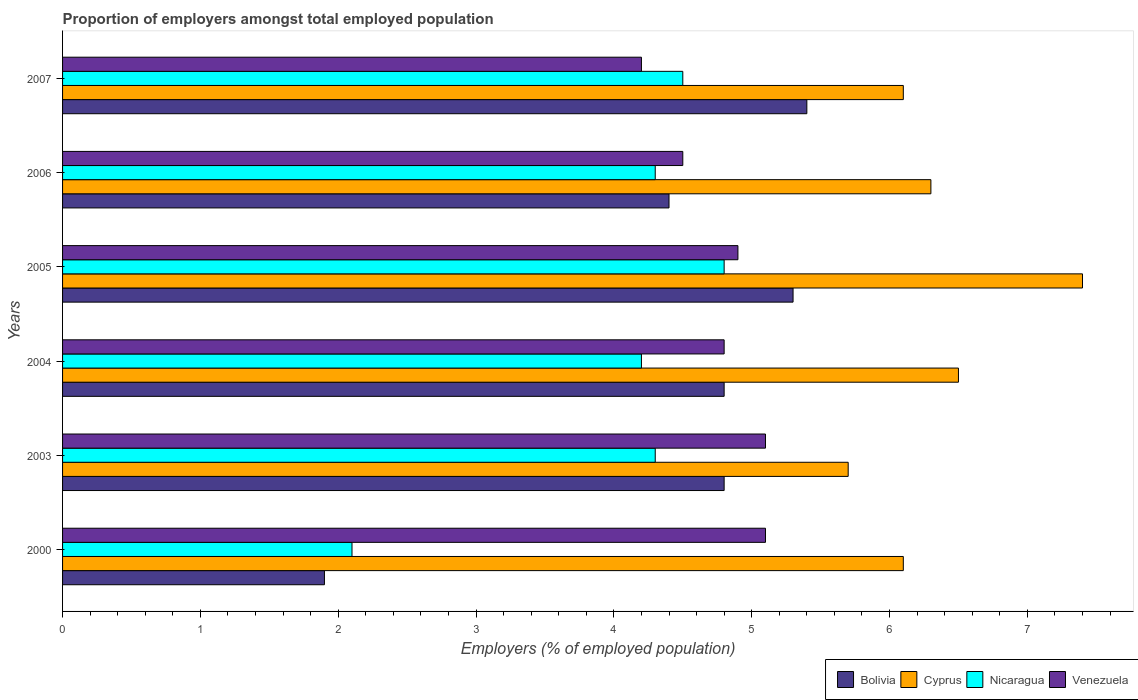How many different coloured bars are there?
Keep it short and to the point. 4. Are the number of bars per tick equal to the number of legend labels?
Your answer should be compact. Yes. How many bars are there on the 4th tick from the top?
Ensure brevity in your answer.  4. In how many cases, is the number of bars for a given year not equal to the number of legend labels?
Make the answer very short. 0. What is the proportion of employers in Venezuela in 2006?
Your response must be concise. 4.5. Across all years, what is the maximum proportion of employers in Venezuela?
Ensure brevity in your answer.  5.1. Across all years, what is the minimum proportion of employers in Venezuela?
Your answer should be very brief. 4.2. What is the total proportion of employers in Nicaragua in the graph?
Your answer should be compact. 24.2. What is the difference between the proportion of employers in Venezuela in 2000 and that in 2006?
Your response must be concise. 0.6. What is the difference between the proportion of employers in Cyprus in 2006 and the proportion of employers in Bolivia in 2007?
Your response must be concise. 0.9. What is the average proportion of employers in Bolivia per year?
Offer a very short reply. 4.43. In the year 2007, what is the difference between the proportion of employers in Nicaragua and proportion of employers in Venezuela?
Make the answer very short. 0.3. In how many years, is the proportion of employers in Venezuela greater than 7.2 %?
Provide a succinct answer. 0. What is the ratio of the proportion of employers in Bolivia in 2000 to that in 2006?
Provide a succinct answer. 0.43. What is the difference between the highest and the second highest proportion of employers in Nicaragua?
Keep it short and to the point. 0.3. What is the difference between the highest and the lowest proportion of employers in Venezuela?
Keep it short and to the point. 0.9. In how many years, is the proportion of employers in Venezuela greater than the average proportion of employers in Venezuela taken over all years?
Offer a very short reply. 4. Is it the case that in every year, the sum of the proportion of employers in Bolivia and proportion of employers in Nicaragua is greater than the sum of proportion of employers in Cyprus and proportion of employers in Venezuela?
Keep it short and to the point. No. What does the 2nd bar from the top in 2000 represents?
Keep it short and to the point. Nicaragua. What does the 4th bar from the bottom in 2007 represents?
Offer a terse response. Venezuela. Are all the bars in the graph horizontal?
Keep it short and to the point. Yes. How many years are there in the graph?
Offer a terse response. 6. What is the difference between two consecutive major ticks on the X-axis?
Your answer should be compact. 1. Are the values on the major ticks of X-axis written in scientific E-notation?
Your answer should be very brief. No. Does the graph contain grids?
Your answer should be compact. No. What is the title of the graph?
Keep it short and to the point. Proportion of employers amongst total employed population. What is the label or title of the X-axis?
Ensure brevity in your answer.  Employers (% of employed population). What is the label or title of the Y-axis?
Offer a terse response. Years. What is the Employers (% of employed population) in Bolivia in 2000?
Provide a short and direct response. 1.9. What is the Employers (% of employed population) of Cyprus in 2000?
Provide a short and direct response. 6.1. What is the Employers (% of employed population) in Nicaragua in 2000?
Make the answer very short. 2.1. What is the Employers (% of employed population) in Venezuela in 2000?
Offer a very short reply. 5.1. What is the Employers (% of employed population) in Bolivia in 2003?
Provide a short and direct response. 4.8. What is the Employers (% of employed population) of Cyprus in 2003?
Make the answer very short. 5.7. What is the Employers (% of employed population) in Nicaragua in 2003?
Your answer should be compact. 4.3. What is the Employers (% of employed population) in Venezuela in 2003?
Your answer should be compact. 5.1. What is the Employers (% of employed population) of Bolivia in 2004?
Give a very brief answer. 4.8. What is the Employers (% of employed population) in Nicaragua in 2004?
Offer a terse response. 4.2. What is the Employers (% of employed population) of Venezuela in 2004?
Your response must be concise. 4.8. What is the Employers (% of employed population) in Bolivia in 2005?
Offer a very short reply. 5.3. What is the Employers (% of employed population) in Cyprus in 2005?
Offer a terse response. 7.4. What is the Employers (% of employed population) in Nicaragua in 2005?
Your answer should be very brief. 4.8. What is the Employers (% of employed population) of Venezuela in 2005?
Provide a succinct answer. 4.9. What is the Employers (% of employed population) of Bolivia in 2006?
Provide a succinct answer. 4.4. What is the Employers (% of employed population) of Cyprus in 2006?
Keep it short and to the point. 6.3. What is the Employers (% of employed population) in Nicaragua in 2006?
Provide a short and direct response. 4.3. What is the Employers (% of employed population) in Venezuela in 2006?
Offer a terse response. 4.5. What is the Employers (% of employed population) in Bolivia in 2007?
Your answer should be very brief. 5.4. What is the Employers (% of employed population) in Cyprus in 2007?
Provide a short and direct response. 6.1. What is the Employers (% of employed population) in Nicaragua in 2007?
Ensure brevity in your answer.  4.5. What is the Employers (% of employed population) in Venezuela in 2007?
Provide a short and direct response. 4.2. Across all years, what is the maximum Employers (% of employed population) in Bolivia?
Offer a terse response. 5.4. Across all years, what is the maximum Employers (% of employed population) in Cyprus?
Make the answer very short. 7.4. Across all years, what is the maximum Employers (% of employed population) of Nicaragua?
Ensure brevity in your answer.  4.8. Across all years, what is the maximum Employers (% of employed population) of Venezuela?
Provide a short and direct response. 5.1. Across all years, what is the minimum Employers (% of employed population) of Bolivia?
Ensure brevity in your answer.  1.9. Across all years, what is the minimum Employers (% of employed population) in Cyprus?
Keep it short and to the point. 5.7. Across all years, what is the minimum Employers (% of employed population) in Nicaragua?
Give a very brief answer. 2.1. Across all years, what is the minimum Employers (% of employed population) of Venezuela?
Give a very brief answer. 4.2. What is the total Employers (% of employed population) in Bolivia in the graph?
Ensure brevity in your answer.  26.6. What is the total Employers (% of employed population) in Cyprus in the graph?
Your answer should be compact. 38.1. What is the total Employers (% of employed population) in Nicaragua in the graph?
Provide a succinct answer. 24.2. What is the total Employers (% of employed population) of Venezuela in the graph?
Keep it short and to the point. 28.6. What is the difference between the Employers (% of employed population) in Venezuela in 2000 and that in 2003?
Your response must be concise. 0. What is the difference between the Employers (% of employed population) in Nicaragua in 2000 and that in 2004?
Provide a succinct answer. -2.1. What is the difference between the Employers (% of employed population) of Nicaragua in 2000 and that in 2005?
Keep it short and to the point. -2.7. What is the difference between the Employers (% of employed population) in Venezuela in 2000 and that in 2005?
Provide a succinct answer. 0.2. What is the difference between the Employers (% of employed population) in Bolivia in 2000 and that in 2006?
Offer a terse response. -2.5. What is the difference between the Employers (% of employed population) in Cyprus in 2000 and that in 2007?
Offer a very short reply. 0. What is the difference between the Employers (% of employed population) in Venezuela in 2000 and that in 2007?
Your answer should be compact. 0.9. What is the difference between the Employers (% of employed population) of Bolivia in 2003 and that in 2004?
Your response must be concise. 0. What is the difference between the Employers (% of employed population) of Cyprus in 2003 and that in 2004?
Provide a succinct answer. -0.8. What is the difference between the Employers (% of employed population) of Nicaragua in 2003 and that in 2004?
Your answer should be very brief. 0.1. What is the difference between the Employers (% of employed population) of Venezuela in 2003 and that in 2004?
Make the answer very short. 0.3. What is the difference between the Employers (% of employed population) of Bolivia in 2003 and that in 2006?
Ensure brevity in your answer.  0.4. What is the difference between the Employers (% of employed population) of Cyprus in 2003 and that in 2006?
Offer a very short reply. -0.6. What is the difference between the Employers (% of employed population) in Nicaragua in 2003 and that in 2006?
Your response must be concise. 0. What is the difference between the Employers (% of employed population) in Nicaragua in 2003 and that in 2007?
Make the answer very short. -0.2. What is the difference between the Employers (% of employed population) in Venezuela in 2003 and that in 2007?
Provide a succinct answer. 0.9. What is the difference between the Employers (% of employed population) of Cyprus in 2004 and that in 2005?
Offer a very short reply. -0.9. What is the difference between the Employers (% of employed population) of Nicaragua in 2004 and that in 2005?
Offer a very short reply. -0.6. What is the difference between the Employers (% of employed population) in Venezuela in 2004 and that in 2005?
Your answer should be compact. -0.1. What is the difference between the Employers (% of employed population) in Bolivia in 2004 and that in 2006?
Provide a short and direct response. 0.4. What is the difference between the Employers (% of employed population) of Nicaragua in 2004 and that in 2006?
Your answer should be very brief. -0.1. What is the difference between the Employers (% of employed population) of Venezuela in 2004 and that in 2006?
Ensure brevity in your answer.  0.3. What is the difference between the Employers (% of employed population) of Bolivia in 2004 and that in 2007?
Keep it short and to the point. -0.6. What is the difference between the Employers (% of employed population) of Nicaragua in 2004 and that in 2007?
Make the answer very short. -0.3. What is the difference between the Employers (% of employed population) of Bolivia in 2005 and that in 2006?
Offer a very short reply. 0.9. What is the difference between the Employers (% of employed population) of Cyprus in 2005 and that in 2006?
Give a very brief answer. 1.1. What is the difference between the Employers (% of employed population) of Venezuela in 2005 and that in 2006?
Offer a terse response. 0.4. What is the difference between the Employers (% of employed population) of Bolivia in 2005 and that in 2007?
Offer a terse response. -0.1. What is the difference between the Employers (% of employed population) of Cyprus in 2005 and that in 2007?
Your response must be concise. 1.3. What is the difference between the Employers (% of employed population) in Venezuela in 2005 and that in 2007?
Give a very brief answer. 0.7. What is the difference between the Employers (% of employed population) in Bolivia in 2006 and that in 2007?
Make the answer very short. -1. What is the difference between the Employers (% of employed population) of Cyprus in 2006 and that in 2007?
Offer a terse response. 0.2. What is the difference between the Employers (% of employed population) of Venezuela in 2006 and that in 2007?
Your answer should be compact. 0.3. What is the difference between the Employers (% of employed population) of Cyprus in 2000 and the Employers (% of employed population) of Nicaragua in 2003?
Your response must be concise. 1.8. What is the difference between the Employers (% of employed population) of Nicaragua in 2000 and the Employers (% of employed population) of Venezuela in 2003?
Keep it short and to the point. -3. What is the difference between the Employers (% of employed population) in Bolivia in 2000 and the Employers (% of employed population) in Venezuela in 2004?
Your answer should be very brief. -2.9. What is the difference between the Employers (% of employed population) of Nicaragua in 2000 and the Employers (% of employed population) of Venezuela in 2004?
Provide a short and direct response. -2.7. What is the difference between the Employers (% of employed population) of Bolivia in 2000 and the Employers (% of employed population) of Cyprus in 2005?
Provide a short and direct response. -5.5. What is the difference between the Employers (% of employed population) in Bolivia in 2000 and the Employers (% of employed population) in Nicaragua in 2005?
Provide a short and direct response. -2.9. What is the difference between the Employers (% of employed population) in Bolivia in 2000 and the Employers (% of employed population) in Venezuela in 2005?
Make the answer very short. -3. What is the difference between the Employers (% of employed population) in Cyprus in 2000 and the Employers (% of employed population) in Nicaragua in 2005?
Ensure brevity in your answer.  1.3. What is the difference between the Employers (% of employed population) of Bolivia in 2000 and the Employers (% of employed population) of Cyprus in 2006?
Keep it short and to the point. -4.4. What is the difference between the Employers (% of employed population) in Bolivia in 2000 and the Employers (% of employed population) in Nicaragua in 2006?
Your answer should be compact. -2.4. What is the difference between the Employers (% of employed population) in Cyprus in 2000 and the Employers (% of employed population) in Venezuela in 2006?
Provide a succinct answer. 1.6. What is the difference between the Employers (% of employed population) of Bolivia in 2000 and the Employers (% of employed population) of Cyprus in 2007?
Keep it short and to the point. -4.2. What is the difference between the Employers (% of employed population) in Bolivia in 2000 and the Employers (% of employed population) in Nicaragua in 2007?
Your answer should be very brief. -2.6. What is the difference between the Employers (% of employed population) in Bolivia in 2000 and the Employers (% of employed population) in Venezuela in 2007?
Your answer should be compact. -2.3. What is the difference between the Employers (% of employed population) of Cyprus in 2000 and the Employers (% of employed population) of Nicaragua in 2007?
Provide a short and direct response. 1.6. What is the difference between the Employers (% of employed population) in Nicaragua in 2000 and the Employers (% of employed population) in Venezuela in 2007?
Make the answer very short. -2.1. What is the difference between the Employers (% of employed population) of Bolivia in 2003 and the Employers (% of employed population) of Cyprus in 2004?
Offer a terse response. -1.7. What is the difference between the Employers (% of employed population) in Bolivia in 2003 and the Employers (% of employed population) in Nicaragua in 2004?
Your answer should be compact. 0.6. What is the difference between the Employers (% of employed population) in Bolivia in 2003 and the Employers (% of employed population) in Venezuela in 2004?
Provide a succinct answer. 0. What is the difference between the Employers (% of employed population) in Cyprus in 2003 and the Employers (% of employed population) in Venezuela in 2004?
Give a very brief answer. 0.9. What is the difference between the Employers (% of employed population) of Nicaragua in 2003 and the Employers (% of employed population) of Venezuela in 2004?
Your answer should be very brief. -0.5. What is the difference between the Employers (% of employed population) in Bolivia in 2003 and the Employers (% of employed population) in Cyprus in 2005?
Your answer should be very brief. -2.6. What is the difference between the Employers (% of employed population) of Bolivia in 2003 and the Employers (% of employed population) of Nicaragua in 2005?
Your answer should be very brief. 0. What is the difference between the Employers (% of employed population) of Cyprus in 2003 and the Employers (% of employed population) of Nicaragua in 2005?
Give a very brief answer. 0.9. What is the difference between the Employers (% of employed population) in Cyprus in 2003 and the Employers (% of employed population) in Venezuela in 2005?
Offer a terse response. 0.8. What is the difference between the Employers (% of employed population) in Bolivia in 2003 and the Employers (% of employed population) in Nicaragua in 2006?
Your response must be concise. 0.5. What is the difference between the Employers (% of employed population) in Cyprus in 2003 and the Employers (% of employed population) in Nicaragua in 2006?
Your answer should be very brief. 1.4. What is the difference between the Employers (% of employed population) of Cyprus in 2003 and the Employers (% of employed population) of Venezuela in 2006?
Keep it short and to the point. 1.2. What is the difference between the Employers (% of employed population) in Bolivia in 2003 and the Employers (% of employed population) in Nicaragua in 2007?
Your response must be concise. 0.3. What is the difference between the Employers (% of employed population) of Nicaragua in 2003 and the Employers (% of employed population) of Venezuela in 2007?
Offer a very short reply. 0.1. What is the difference between the Employers (% of employed population) in Bolivia in 2004 and the Employers (% of employed population) in Cyprus in 2005?
Give a very brief answer. -2.6. What is the difference between the Employers (% of employed population) in Bolivia in 2004 and the Employers (% of employed population) in Nicaragua in 2005?
Offer a terse response. 0. What is the difference between the Employers (% of employed population) in Bolivia in 2004 and the Employers (% of employed population) in Venezuela in 2005?
Your answer should be compact. -0.1. What is the difference between the Employers (% of employed population) of Cyprus in 2004 and the Employers (% of employed population) of Nicaragua in 2005?
Make the answer very short. 1.7. What is the difference between the Employers (% of employed population) of Nicaragua in 2004 and the Employers (% of employed population) of Venezuela in 2005?
Give a very brief answer. -0.7. What is the difference between the Employers (% of employed population) in Cyprus in 2004 and the Employers (% of employed population) in Nicaragua in 2006?
Your answer should be compact. 2.2. What is the difference between the Employers (% of employed population) in Bolivia in 2004 and the Employers (% of employed population) in Venezuela in 2007?
Make the answer very short. 0.6. What is the difference between the Employers (% of employed population) in Cyprus in 2004 and the Employers (% of employed population) in Nicaragua in 2007?
Offer a terse response. 2. What is the difference between the Employers (% of employed population) in Bolivia in 2005 and the Employers (% of employed population) in Venezuela in 2006?
Provide a succinct answer. 0.8. What is the difference between the Employers (% of employed population) in Cyprus in 2005 and the Employers (% of employed population) in Nicaragua in 2006?
Ensure brevity in your answer.  3.1. What is the difference between the Employers (% of employed population) in Nicaragua in 2005 and the Employers (% of employed population) in Venezuela in 2006?
Provide a short and direct response. 0.3. What is the difference between the Employers (% of employed population) of Bolivia in 2005 and the Employers (% of employed population) of Cyprus in 2007?
Make the answer very short. -0.8. What is the difference between the Employers (% of employed population) of Bolivia in 2005 and the Employers (% of employed population) of Nicaragua in 2007?
Keep it short and to the point. 0.8. What is the difference between the Employers (% of employed population) of Bolivia in 2005 and the Employers (% of employed population) of Venezuela in 2007?
Your answer should be very brief. 1.1. What is the difference between the Employers (% of employed population) in Cyprus in 2005 and the Employers (% of employed population) in Nicaragua in 2007?
Your answer should be very brief. 2.9. What is the difference between the Employers (% of employed population) of Bolivia in 2006 and the Employers (% of employed population) of Cyprus in 2007?
Offer a terse response. -1.7. What is the difference between the Employers (% of employed population) of Bolivia in 2006 and the Employers (% of employed population) of Nicaragua in 2007?
Your response must be concise. -0.1. What is the difference between the Employers (% of employed population) in Cyprus in 2006 and the Employers (% of employed population) in Nicaragua in 2007?
Give a very brief answer. 1.8. What is the average Employers (% of employed population) of Bolivia per year?
Make the answer very short. 4.43. What is the average Employers (% of employed population) in Cyprus per year?
Offer a terse response. 6.35. What is the average Employers (% of employed population) in Nicaragua per year?
Give a very brief answer. 4.03. What is the average Employers (% of employed population) of Venezuela per year?
Ensure brevity in your answer.  4.77. In the year 2000, what is the difference between the Employers (% of employed population) in Bolivia and Employers (% of employed population) in Cyprus?
Make the answer very short. -4.2. In the year 2000, what is the difference between the Employers (% of employed population) of Bolivia and Employers (% of employed population) of Nicaragua?
Make the answer very short. -0.2. In the year 2000, what is the difference between the Employers (% of employed population) of Bolivia and Employers (% of employed population) of Venezuela?
Offer a very short reply. -3.2. In the year 2000, what is the difference between the Employers (% of employed population) of Nicaragua and Employers (% of employed population) of Venezuela?
Offer a terse response. -3. In the year 2003, what is the difference between the Employers (% of employed population) in Cyprus and Employers (% of employed population) in Venezuela?
Offer a terse response. 0.6. In the year 2003, what is the difference between the Employers (% of employed population) in Nicaragua and Employers (% of employed population) in Venezuela?
Keep it short and to the point. -0.8. In the year 2004, what is the difference between the Employers (% of employed population) in Bolivia and Employers (% of employed population) in Cyprus?
Offer a very short reply. -1.7. In the year 2004, what is the difference between the Employers (% of employed population) of Bolivia and Employers (% of employed population) of Venezuela?
Ensure brevity in your answer.  0. In the year 2004, what is the difference between the Employers (% of employed population) in Cyprus and Employers (% of employed population) in Nicaragua?
Give a very brief answer. 2.3. In the year 2004, what is the difference between the Employers (% of employed population) in Nicaragua and Employers (% of employed population) in Venezuela?
Give a very brief answer. -0.6. In the year 2005, what is the difference between the Employers (% of employed population) in Bolivia and Employers (% of employed population) in Cyprus?
Ensure brevity in your answer.  -2.1. In the year 2005, what is the difference between the Employers (% of employed population) of Bolivia and Employers (% of employed population) of Nicaragua?
Provide a succinct answer. 0.5. In the year 2005, what is the difference between the Employers (% of employed population) of Cyprus and Employers (% of employed population) of Nicaragua?
Keep it short and to the point. 2.6. In the year 2005, what is the difference between the Employers (% of employed population) of Cyprus and Employers (% of employed population) of Venezuela?
Offer a terse response. 2.5. In the year 2006, what is the difference between the Employers (% of employed population) of Bolivia and Employers (% of employed population) of Cyprus?
Provide a short and direct response. -1.9. In the year 2006, what is the difference between the Employers (% of employed population) in Bolivia and Employers (% of employed population) in Nicaragua?
Your answer should be very brief. 0.1. In the year 2006, what is the difference between the Employers (% of employed population) in Nicaragua and Employers (% of employed population) in Venezuela?
Keep it short and to the point. -0.2. In the year 2007, what is the difference between the Employers (% of employed population) of Bolivia and Employers (% of employed population) of Nicaragua?
Your answer should be compact. 0.9. In the year 2007, what is the difference between the Employers (% of employed population) in Bolivia and Employers (% of employed population) in Venezuela?
Give a very brief answer. 1.2. What is the ratio of the Employers (% of employed population) in Bolivia in 2000 to that in 2003?
Give a very brief answer. 0.4. What is the ratio of the Employers (% of employed population) in Cyprus in 2000 to that in 2003?
Keep it short and to the point. 1.07. What is the ratio of the Employers (% of employed population) in Nicaragua in 2000 to that in 2003?
Ensure brevity in your answer.  0.49. What is the ratio of the Employers (% of employed population) of Venezuela in 2000 to that in 2003?
Ensure brevity in your answer.  1. What is the ratio of the Employers (% of employed population) of Bolivia in 2000 to that in 2004?
Offer a terse response. 0.4. What is the ratio of the Employers (% of employed population) in Cyprus in 2000 to that in 2004?
Give a very brief answer. 0.94. What is the ratio of the Employers (% of employed population) in Bolivia in 2000 to that in 2005?
Make the answer very short. 0.36. What is the ratio of the Employers (% of employed population) of Cyprus in 2000 to that in 2005?
Offer a very short reply. 0.82. What is the ratio of the Employers (% of employed population) of Nicaragua in 2000 to that in 2005?
Offer a very short reply. 0.44. What is the ratio of the Employers (% of employed population) in Venezuela in 2000 to that in 2005?
Provide a succinct answer. 1.04. What is the ratio of the Employers (% of employed population) of Bolivia in 2000 to that in 2006?
Give a very brief answer. 0.43. What is the ratio of the Employers (% of employed population) of Cyprus in 2000 to that in 2006?
Your response must be concise. 0.97. What is the ratio of the Employers (% of employed population) of Nicaragua in 2000 to that in 2006?
Your answer should be compact. 0.49. What is the ratio of the Employers (% of employed population) of Venezuela in 2000 to that in 2006?
Your answer should be very brief. 1.13. What is the ratio of the Employers (% of employed population) of Bolivia in 2000 to that in 2007?
Make the answer very short. 0.35. What is the ratio of the Employers (% of employed population) in Nicaragua in 2000 to that in 2007?
Ensure brevity in your answer.  0.47. What is the ratio of the Employers (% of employed population) in Venezuela in 2000 to that in 2007?
Offer a very short reply. 1.21. What is the ratio of the Employers (% of employed population) of Bolivia in 2003 to that in 2004?
Your answer should be compact. 1. What is the ratio of the Employers (% of employed population) in Cyprus in 2003 to that in 2004?
Your response must be concise. 0.88. What is the ratio of the Employers (% of employed population) of Nicaragua in 2003 to that in 2004?
Your answer should be very brief. 1.02. What is the ratio of the Employers (% of employed population) in Venezuela in 2003 to that in 2004?
Offer a very short reply. 1.06. What is the ratio of the Employers (% of employed population) of Bolivia in 2003 to that in 2005?
Keep it short and to the point. 0.91. What is the ratio of the Employers (% of employed population) in Cyprus in 2003 to that in 2005?
Keep it short and to the point. 0.77. What is the ratio of the Employers (% of employed population) in Nicaragua in 2003 to that in 2005?
Your response must be concise. 0.9. What is the ratio of the Employers (% of employed population) of Venezuela in 2003 to that in 2005?
Your answer should be very brief. 1.04. What is the ratio of the Employers (% of employed population) of Bolivia in 2003 to that in 2006?
Make the answer very short. 1.09. What is the ratio of the Employers (% of employed population) of Cyprus in 2003 to that in 2006?
Your answer should be compact. 0.9. What is the ratio of the Employers (% of employed population) of Venezuela in 2003 to that in 2006?
Offer a very short reply. 1.13. What is the ratio of the Employers (% of employed population) in Bolivia in 2003 to that in 2007?
Your answer should be very brief. 0.89. What is the ratio of the Employers (% of employed population) of Cyprus in 2003 to that in 2007?
Provide a succinct answer. 0.93. What is the ratio of the Employers (% of employed population) in Nicaragua in 2003 to that in 2007?
Your answer should be compact. 0.96. What is the ratio of the Employers (% of employed population) of Venezuela in 2003 to that in 2007?
Offer a very short reply. 1.21. What is the ratio of the Employers (% of employed population) in Bolivia in 2004 to that in 2005?
Ensure brevity in your answer.  0.91. What is the ratio of the Employers (% of employed population) of Cyprus in 2004 to that in 2005?
Offer a very short reply. 0.88. What is the ratio of the Employers (% of employed population) in Venezuela in 2004 to that in 2005?
Offer a very short reply. 0.98. What is the ratio of the Employers (% of employed population) of Bolivia in 2004 to that in 2006?
Your answer should be compact. 1.09. What is the ratio of the Employers (% of employed population) of Cyprus in 2004 to that in 2006?
Provide a short and direct response. 1.03. What is the ratio of the Employers (% of employed population) of Nicaragua in 2004 to that in 2006?
Your response must be concise. 0.98. What is the ratio of the Employers (% of employed population) of Venezuela in 2004 to that in 2006?
Make the answer very short. 1.07. What is the ratio of the Employers (% of employed population) of Cyprus in 2004 to that in 2007?
Keep it short and to the point. 1.07. What is the ratio of the Employers (% of employed population) of Nicaragua in 2004 to that in 2007?
Provide a succinct answer. 0.93. What is the ratio of the Employers (% of employed population) in Venezuela in 2004 to that in 2007?
Give a very brief answer. 1.14. What is the ratio of the Employers (% of employed population) in Bolivia in 2005 to that in 2006?
Offer a very short reply. 1.2. What is the ratio of the Employers (% of employed population) in Cyprus in 2005 to that in 2006?
Your answer should be very brief. 1.17. What is the ratio of the Employers (% of employed population) of Nicaragua in 2005 to that in 2006?
Offer a very short reply. 1.12. What is the ratio of the Employers (% of employed population) in Venezuela in 2005 to that in 2006?
Keep it short and to the point. 1.09. What is the ratio of the Employers (% of employed population) of Bolivia in 2005 to that in 2007?
Make the answer very short. 0.98. What is the ratio of the Employers (% of employed population) in Cyprus in 2005 to that in 2007?
Provide a short and direct response. 1.21. What is the ratio of the Employers (% of employed population) of Nicaragua in 2005 to that in 2007?
Offer a very short reply. 1.07. What is the ratio of the Employers (% of employed population) in Venezuela in 2005 to that in 2007?
Offer a terse response. 1.17. What is the ratio of the Employers (% of employed population) of Bolivia in 2006 to that in 2007?
Provide a succinct answer. 0.81. What is the ratio of the Employers (% of employed population) of Cyprus in 2006 to that in 2007?
Make the answer very short. 1.03. What is the ratio of the Employers (% of employed population) of Nicaragua in 2006 to that in 2007?
Give a very brief answer. 0.96. What is the ratio of the Employers (% of employed population) of Venezuela in 2006 to that in 2007?
Make the answer very short. 1.07. What is the difference between the highest and the second highest Employers (% of employed population) of Cyprus?
Offer a terse response. 0.9. What is the difference between the highest and the second highest Employers (% of employed population) in Nicaragua?
Offer a very short reply. 0.3. What is the difference between the highest and the lowest Employers (% of employed population) in Nicaragua?
Provide a short and direct response. 2.7. What is the difference between the highest and the lowest Employers (% of employed population) in Venezuela?
Give a very brief answer. 0.9. 